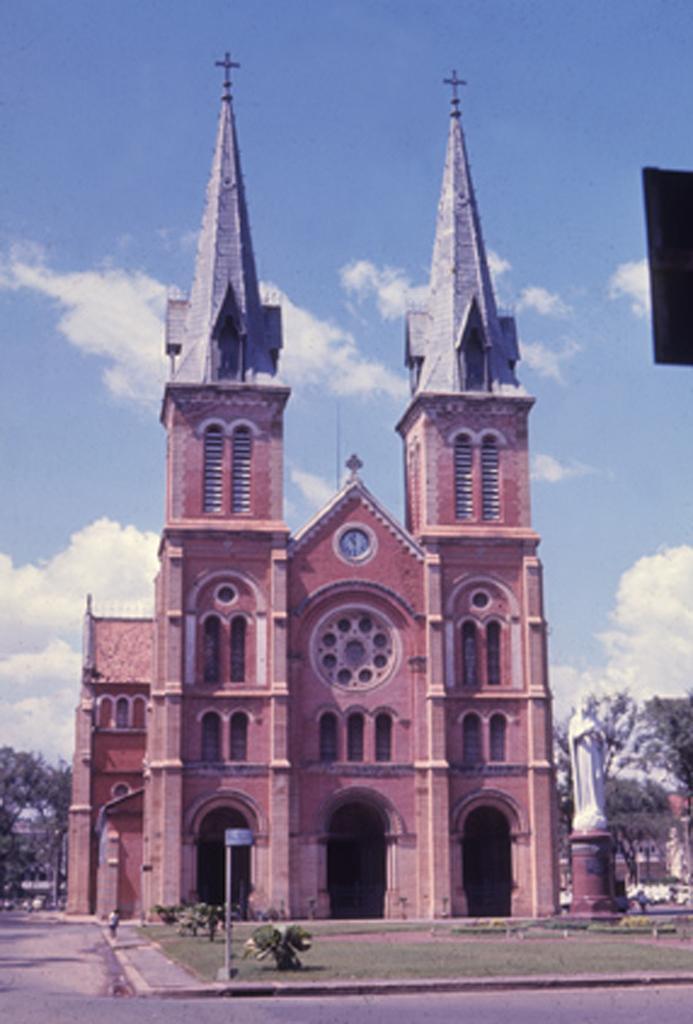Could you give a brief overview of what you see in this image? In this image I can see a road and a pole in the front. In the background I can see an open grass ground, few plants, a sculpture, a building, clouds and the sky. I can also see few trees on the both sides of the image. 